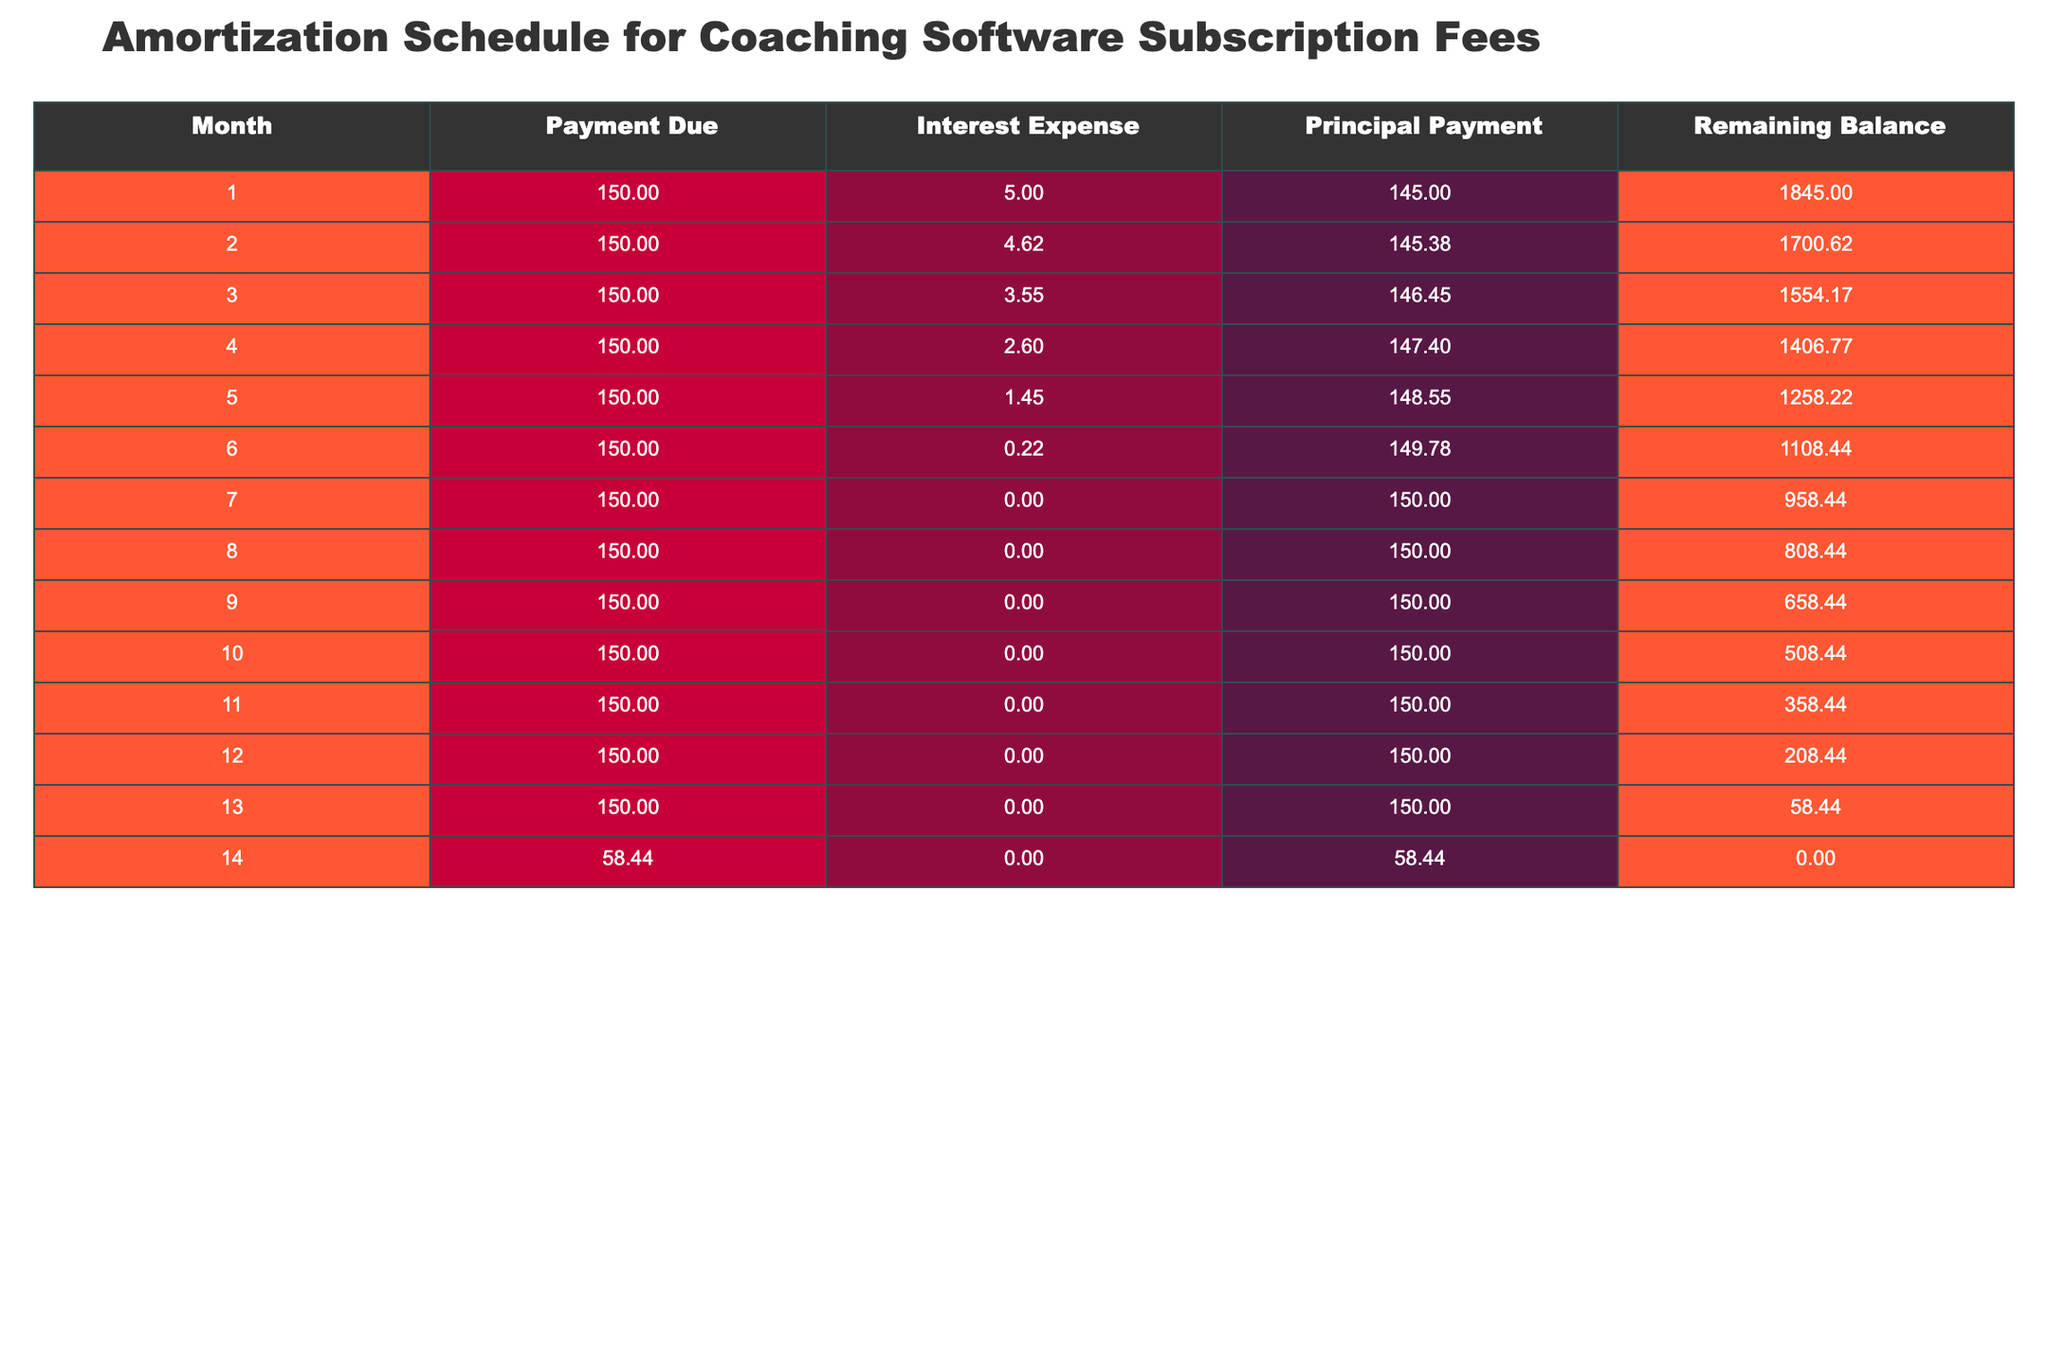What was the payment due in month 5? In month 5, the table shows the payment due is 150.
Answer: 150 What is the interest expense for month 3? The interest expense for month 3, as indicated in the table, is 3.55.
Answer: 3.55 How much was the total principal payment made in the first 6 months? To find the total principal payment for the first 6 months, I sum the principal payments: 145 + 145.38 + 146.45 + 147.40 + 148.55 + 149.78 = 882.56.
Answer: 882.56 Is the remaining balance in month 14 zero? The table shows that the remaining balance in month 14 is indeed 0, confirming the payment was fully settled.
Answer: Yes In which month did the monthly payment decrease from 150 to 58.44? The payment dropped to 58.44 in month 14, as stated in the table.
Answer: Month 14 What is the average interest expense over the 14 months? To find the average interest expense, sum all the interest expenses for the 14 months: 5 + 4.62 + 3.55 + 2.60 + 1.45 + 0.22 + 0 + 0 + 0 + 0 + 0 + 0 + 0 + 0 = 17.44. Then divide by 14 months to get the average: 17.44 / 14 ≈ 1.2457.
Answer: Approximately 1.25 How much principal payment was made in month 6 compared to month 4? In month 6, the principal payment was 149.78 while in month 4 it was 147.40. Thus, the difference is 149.78 - 147.40 = 2.38 more in month 6.
Answer: 2.38 more Was there any interest expense in month 7? The table indicates that there was no interest expense in month 7, as it shows 0.
Answer: No How much is the remaining balance at the end of month 12? The remaining balance at the end of month 12 is 208.44, as stated in the table.
Answer: 208.44 